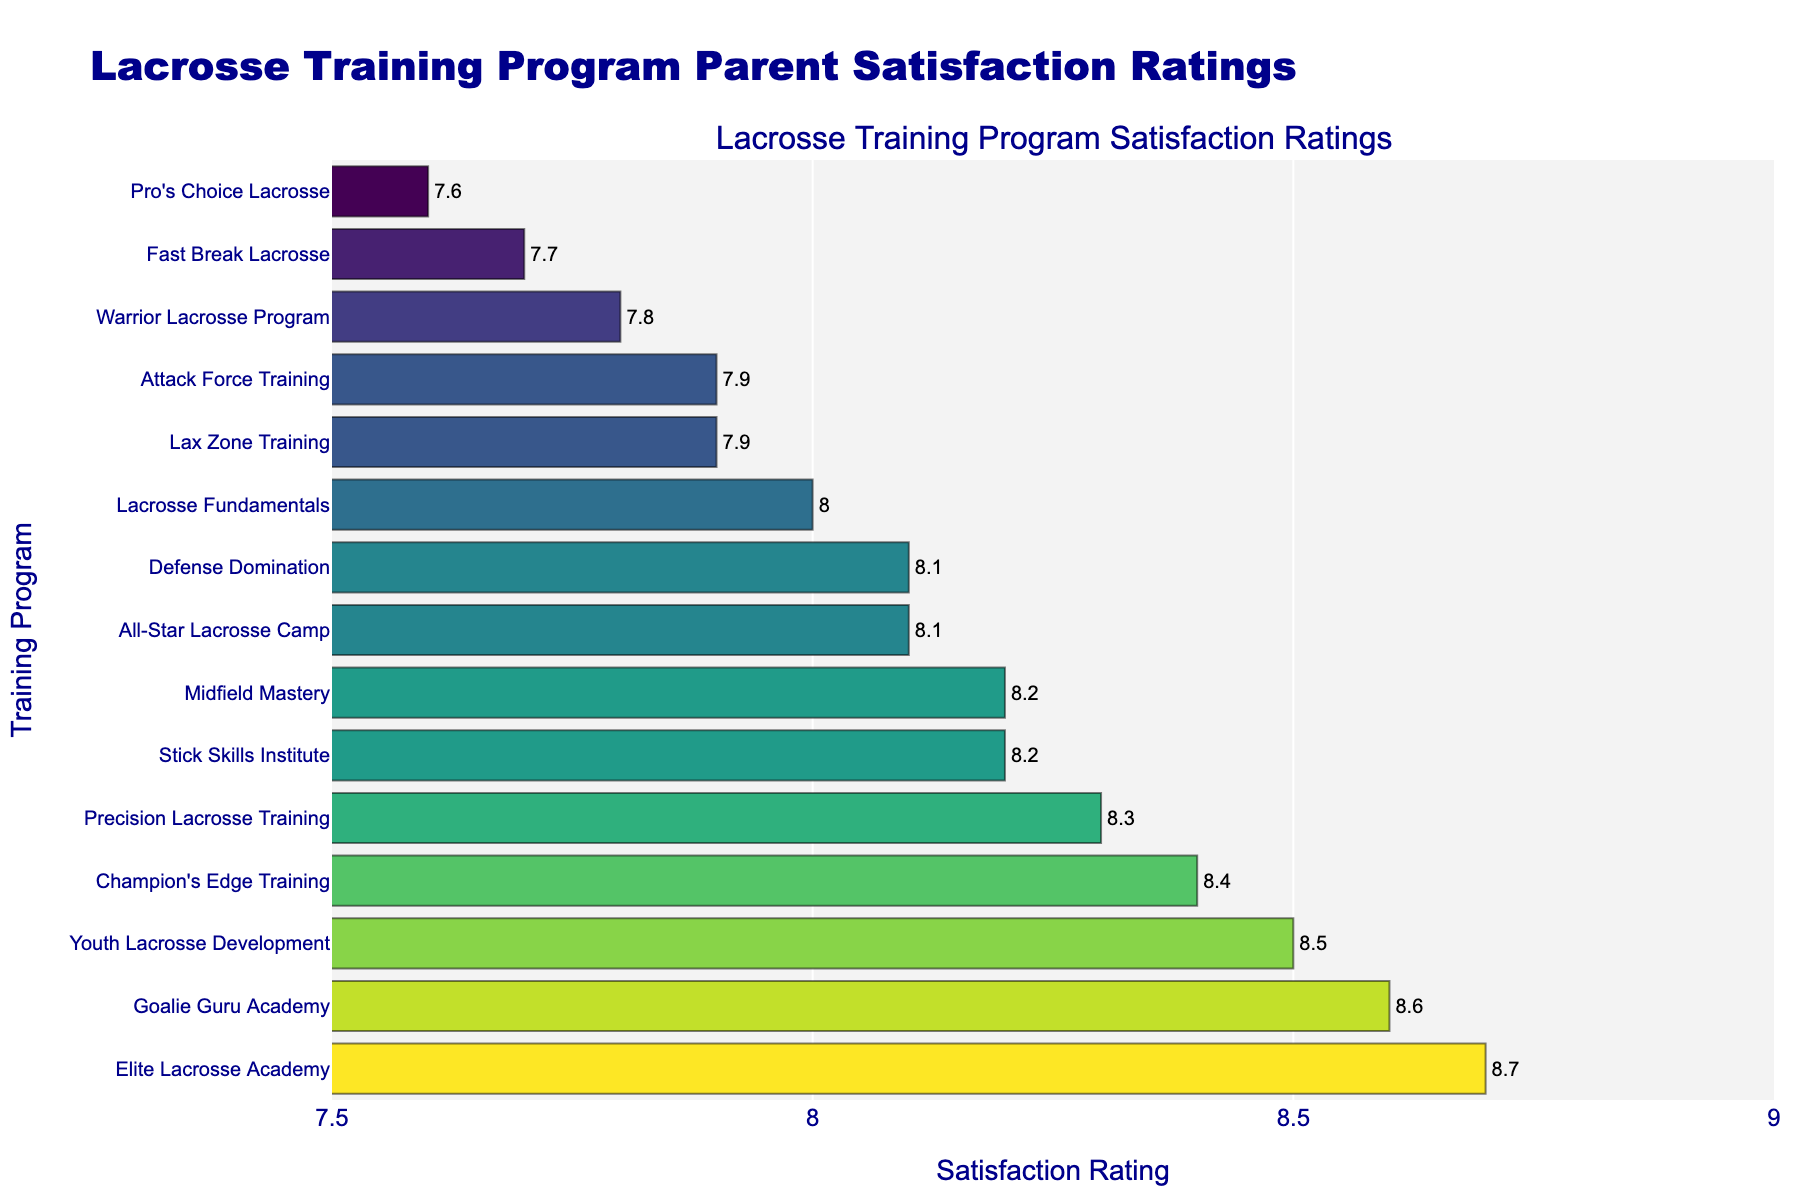Which program has the highest parent satisfaction rating? By looking at the top of the bar chart, we can see which bar is the longest. The longest bar represents the program with the highest satisfaction rating.
Answer: Elite Lacrosse Academy Which program has a parent satisfaction rating of 8.1? Locate the bars with a text value of 8.1 on the chart. There are two such bars.
Answer: All-Star Lacrosse Camp and Defense Domination Which program has a lower satisfaction rating, Lax Zone Training or Youth Lacrosse Development? Compare the lengths of the bars for Lax Zone Training and Youth Lacrosse Development. The shorter bar has the lower satisfaction rating.
Answer: Lax Zone Training What is the average satisfaction rating of the top three programs? Find the satisfaction ratings of the top three programs: 8.7, 8.6, and 8.5. Calculate the average by summing them up and dividing by 3: (8.7 + 8.6 + 8.5) / 3.
Answer: 8.6 How many programs have a satisfaction rating of 8.2 or higher? Count the bars that are 8.2 or longer.
Answer: 8 programs Which programs have a satisfaction rating lower than 8.0 but higher than 7.7? Identify the bars between 7.7 and 8.0 based on their lengths and text values.
Answer: Lax Zone Training, Warrior Lacrosse Program, and Attack Force Training Compare the satisfaction ratings of Goalie Guru Academy and Champion's Edge Training. What is the difference? Subtract the satisfaction rating of Champion's Edge Training (8.4) from Goalie Guru Academy (8.6).
Answer: 0.2 What is the median satisfaction rating of all programs? List all satisfaction ratings in numerical order: 7.6, 7.7, 7.8, 7.9, 7.9, 8.0, 8.1, 8.1, 8.2, 8.2, 8.3, 8.4, 8.5, 8.6, 8.7. The median value is the middle one in an ordered list: 8.2.
Answer: 8.2 Which program's bar is colored the darkest? The color scale used in the chart makes longer bars darker. Identify the longest bar to find the darkest color.
Answer: Elite Lacrosse Academy 